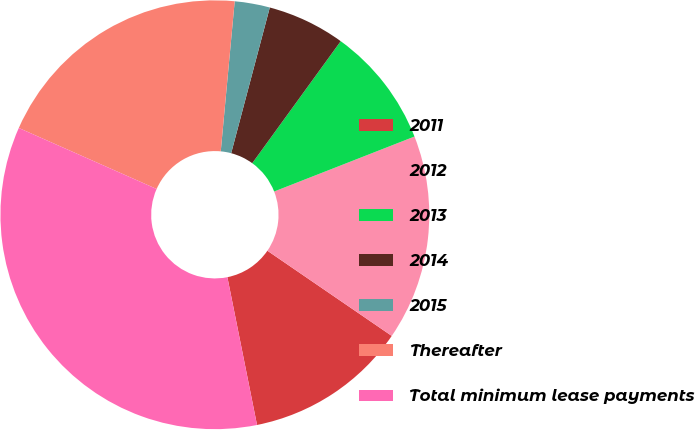<chart> <loc_0><loc_0><loc_500><loc_500><pie_chart><fcel>2011<fcel>2012<fcel>2013<fcel>2014<fcel>2015<fcel>Thereafter<fcel>Total minimum lease payments<nl><fcel>12.29%<fcel>15.5%<fcel>9.07%<fcel>5.86%<fcel>2.65%<fcel>19.84%<fcel>34.78%<nl></chart> 